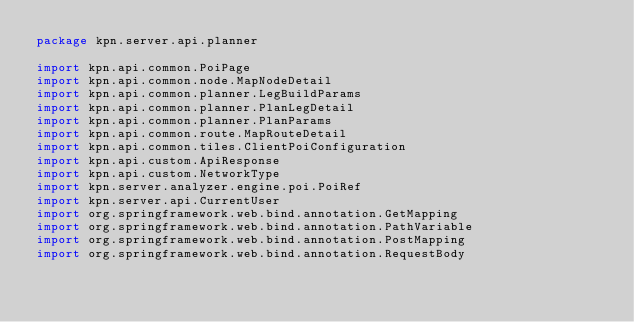<code> <loc_0><loc_0><loc_500><loc_500><_Scala_>package kpn.server.api.planner

import kpn.api.common.PoiPage
import kpn.api.common.node.MapNodeDetail
import kpn.api.common.planner.LegBuildParams
import kpn.api.common.planner.PlanLegDetail
import kpn.api.common.planner.PlanParams
import kpn.api.common.route.MapRouteDetail
import kpn.api.common.tiles.ClientPoiConfiguration
import kpn.api.custom.ApiResponse
import kpn.api.custom.NetworkType
import kpn.server.analyzer.engine.poi.PoiRef
import kpn.server.api.CurrentUser
import org.springframework.web.bind.annotation.GetMapping
import org.springframework.web.bind.annotation.PathVariable
import org.springframework.web.bind.annotation.PostMapping
import org.springframework.web.bind.annotation.RequestBody</code> 